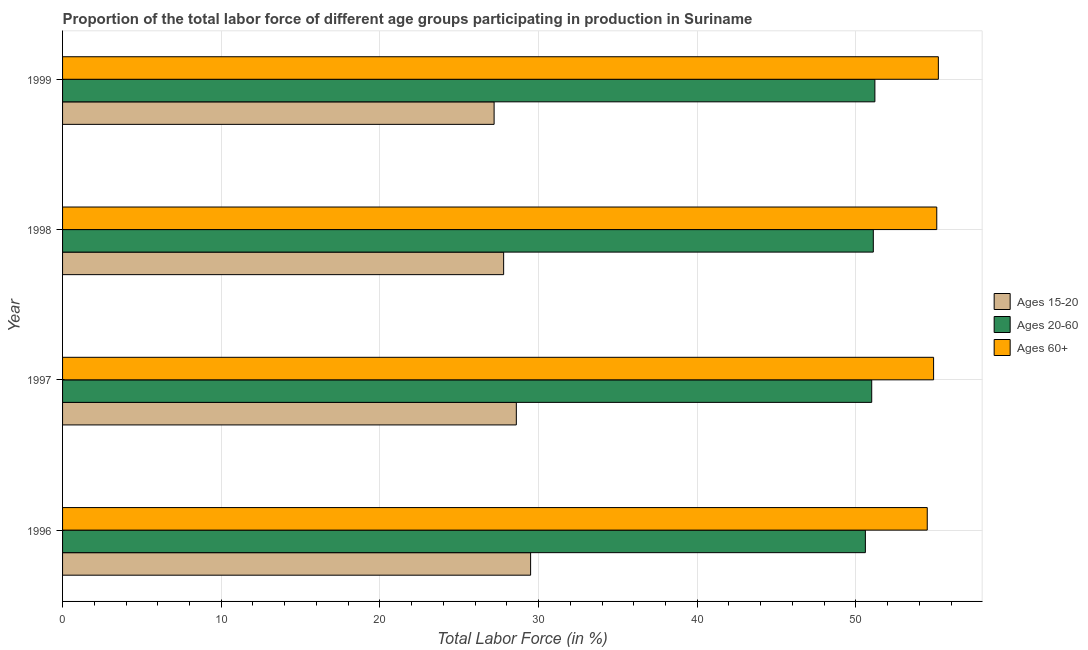How many different coloured bars are there?
Give a very brief answer. 3. How many groups of bars are there?
Provide a short and direct response. 4. How many bars are there on the 3rd tick from the top?
Offer a very short reply. 3. What is the percentage of labor force above age 60 in 1996?
Provide a succinct answer. 54.5. Across all years, what is the maximum percentage of labor force within the age group 15-20?
Give a very brief answer. 29.5. Across all years, what is the minimum percentage of labor force above age 60?
Offer a very short reply. 54.5. In which year was the percentage of labor force within the age group 15-20 minimum?
Your response must be concise. 1999. What is the total percentage of labor force within the age group 20-60 in the graph?
Your answer should be compact. 203.9. What is the difference between the percentage of labor force within the age group 15-20 in 1997 and that in 1999?
Provide a succinct answer. 1.4. What is the difference between the percentage of labor force within the age group 15-20 in 1998 and the percentage of labor force above age 60 in 1996?
Provide a short and direct response. -26.7. What is the average percentage of labor force within the age group 15-20 per year?
Keep it short and to the point. 28.27. In how many years, is the percentage of labor force within the age group 15-20 greater than 54 %?
Offer a very short reply. 0. What is the ratio of the percentage of labor force within the age group 15-20 in 1996 to that in 1997?
Offer a very short reply. 1.03. Is the difference between the percentage of labor force within the age group 20-60 in 1998 and 1999 greater than the difference between the percentage of labor force above age 60 in 1998 and 1999?
Provide a short and direct response. No. What is the difference between the highest and the second highest percentage of labor force within the age group 20-60?
Keep it short and to the point. 0.1. What is the difference between the highest and the lowest percentage of labor force within the age group 15-20?
Offer a very short reply. 2.3. What does the 3rd bar from the top in 1996 represents?
Make the answer very short. Ages 15-20. What does the 1st bar from the bottom in 1996 represents?
Ensure brevity in your answer.  Ages 15-20. Is it the case that in every year, the sum of the percentage of labor force within the age group 15-20 and percentage of labor force within the age group 20-60 is greater than the percentage of labor force above age 60?
Make the answer very short. Yes. How many bars are there?
Make the answer very short. 12. Are all the bars in the graph horizontal?
Ensure brevity in your answer.  Yes. How many years are there in the graph?
Offer a terse response. 4. Are the values on the major ticks of X-axis written in scientific E-notation?
Offer a terse response. No. Does the graph contain any zero values?
Keep it short and to the point. No. Does the graph contain grids?
Offer a terse response. Yes. How many legend labels are there?
Give a very brief answer. 3. How are the legend labels stacked?
Offer a very short reply. Vertical. What is the title of the graph?
Make the answer very short. Proportion of the total labor force of different age groups participating in production in Suriname. What is the label or title of the X-axis?
Make the answer very short. Total Labor Force (in %). What is the Total Labor Force (in %) in Ages 15-20 in 1996?
Your answer should be compact. 29.5. What is the Total Labor Force (in %) of Ages 20-60 in 1996?
Ensure brevity in your answer.  50.6. What is the Total Labor Force (in %) in Ages 60+ in 1996?
Provide a succinct answer. 54.5. What is the Total Labor Force (in %) of Ages 15-20 in 1997?
Make the answer very short. 28.6. What is the Total Labor Force (in %) of Ages 60+ in 1997?
Your answer should be compact. 54.9. What is the Total Labor Force (in %) of Ages 15-20 in 1998?
Offer a very short reply. 27.8. What is the Total Labor Force (in %) in Ages 20-60 in 1998?
Keep it short and to the point. 51.1. What is the Total Labor Force (in %) in Ages 60+ in 1998?
Your response must be concise. 55.1. What is the Total Labor Force (in %) of Ages 15-20 in 1999?
Keep it short and to the point. 27.2. What is the Total Labor Force (in %) of Ages 20-60 in 1999?
Keep it short and to the point. 51.2. What is the Total Labor Force (in %) in Ages 60+ in 1999?
Offer a very short reply. 55.2. Across all years, what is the maximum Total Labor Force (in %) of Ages 15-20?
Offer a very short reply. 29.5. Across all years, what is the maximum Total Labor Force (in %) of Ages 20-60?
Provide a succinct answer. 51.2. Across all years, what is the maximum Total Labor Force (in %) in Ages 60+?
Make the answer very short. 55.2. Across all years, what is the minimum Total Labor Force (in %) of Ages 15-20?
Provide a short and direct response. 27.2. Across all years, what is the minimum Total Labor Force (in %) of Ages 20-60?
Give a very brief answer. 50.6. Across all years, what is the minimum Total Labor Force (in %) of Ages 60+?
Keep it short and to the point. 54.5. What is the total Total Labor Force (in %) of Ages 15-20 in the graph?
Ensure brevity in your answer.  113.1. What is the total Total Labor Force (in %) in Ages 20-60 in the graph?
Provide a succinct answer. 203.9. What is the total Total Labor Force (in %) in Ages 60+ in the graph?
Offer a terse response. 219.7. What is the difference between the Total Labor Force (in %) of Ages 20-60 in 1996 and that in 1997?
Provide a succinct answer. -0.4. What is the difference between the Total Labor Force (in %) in Ages 60+ in 1996 and that in 1997?
Provide a succinct answer. -0.4. What is the difference between the Total Labor Force (in %) of Ages 15-20 in 1996 and that in 1998?
Provide a short and direct response. 1.7. What is the difference between the Total Labor Force (in %) in Ages 60+ in 1996 and that in 1998?
Offer a terse response. -0.6. What is the difference between the Total Labor Force (in %) in Ages 20-60 in 1996 and that in 1999?
Make the answer very short. -0.6. What is the difference between the Total Labor Force (in %) in Ages 60+ in 1996 and that in 1999?
Give a very brief answer. -0.7. What is the difference between the Total Labor Force (in %) in Ages 15-20 in 1997 and that in 1998?
Provide a short and direct response. 0.8. What is the difference between the Total Labor Force (in %) in Ages 60+ in 1997 and that in 1998?
Your answer should be compact. -0.2. What is the difference between the Total Labor Force (in %) of Ages 15-20 in 1997 and that in 1999?
Offer a terse response. 1.4. What is the difference between the Total Labor Force (in %) of Ages 20-60 in 1997 and that in 1999?
Make the answer very short. -0.2. What is the difference between the Total Labor Force (in %) in Ages 15-20 in 1996 and the Total Labor Force (in %) in Ages 20-60 in 1997?
Your response must be concise. -21.5. What is the difference between the Total Labor Force (in %) of Ages 15-20 in 1996 and the Total Labor Force (in %) of Ages 60+ in 1997?
Give a very brief answer. -25.4. What is the difference between the Total Labor Force (in %) in Ages 20-60 in 1996 and the Total Labor Force (in %) in Ages 60+ in 1997?
Ensure brevity in your answer.  -4.3. What is the difference between the Total Labor Force (in %) of Ages 15-20 in 1996 and the Total Labor Force (in %) of Ages 20-60 in 1998?
Offer a very short reply. -21.6. What is the difference between the Total Labor Force (in %) of Ages 15-20 in 1996 and the Total Labor Force (in %) of Ages 60+ in 1998?
Offer a very short reply. -25.6. What is the difference between the Total Labor Force (in %) in Ages 20-60 in 1996 and the Total Labor Force (in %) in Ages 60+ in 1998?
Your response must be concise. -4.5. What is the difference between the Total Labor Force (in %) of Ages 15-20 in 1996 and the Total Labor Force (in %) of Ages 20-60 in 1999?
Provide a succinct answer. -21.7. What is the difference between the Total Labor Force (in %) of Ages 15-20 in 1996 and the Total Labor Force (in %) of Ages 60+ in 1999?
Ensure brevity in your answer.  -25.7. What is the difference between the Total Labor Force (in %) of Ages 15-20 in 1997 and the Total Labor Force (in %) of Ages 20-60 in 1998?
Ensure brevity in your answer.  -22.5. What is the difference between the Total Labor Force (in %) in Ages 15-20 in 1997 and the Total Labor Force (in %) in Ages 60+ in 1998?
Provide a short and direct response. -26.5. What is the difference between the Total Labor Force (in %) in Ages 20-60 in 1997 and the Total Labor Force (in %) in Ages 60+ in 1998?
Provide a succinct answer. -4.1. What is the difference between the Total Labor Force (in %) of Ages 15-20 in 1997 and the Total Labor Force (in %) of Ages 20-60 in 1999?
Provide a succinct answer. -22.6. What is the difference between the Total Labor Force (in %) in Ages 15-20 in 1997 and the Total Labor Force (in %) in Ages 60+ in 1999?
Your response must be concise. -26.6. What is the difference between the Total Labor Force (in %) in Ages 15-20 in 1998 and the Total Labor Force (in %) in Ages 20-60 in 1999?
Your response must be concise. -23.4. What is the difference between the Total Labor Force (in %) of Ages 15-20 in 1998 and the Total Labor Force (in %) of Ages 60+ in 1999?
Offer a terse response. -27.4. What is the difference between the Total Labor Force (in %) of Ages 20-60 in 1998 and the Total Labor Force (in %) of Ages 60+ in 1999?
Keep it short and to the point. -4.1. What is the average Total Labor Force (in %) of Ages 15-20 per year?
Offer a terse response. 28.27. What is the average Total Labor Force (in %) in Ages 20-60 per year?
Your response must be concise. 50.98. What is the average Total Labor Force (in %) of Ages 60+ per year?
Provide a succinct answer. 54.92. In the year 1996, what is the difference between the Total Labor Force (in %) of Ages 15-20 and Total Labor Force (in %) of Ages 20-60?
Offer a very short reply. -21.1. In the year 1997, what is the difference between the Total Labor Force (in %) of Ages 15-20 and Total Labor Force (in %) of Ages 20-60?
Your response must be concise. -22.4. In the year 1997, what is the difference between the Total Labor Force (in %) of Ages 15-20 and Total Labor Force (in %) of Ages 60+?
Provide a short and direct response. -26.3. In the year 1998, what is the difference between the Total Labor Force (in %) in Ages 15-20 and Total Labor Force (in %) in Ages 20-60?
Your response must be concise. -23.3. In the year 1998, what is the difference between the Total Labor Force (in %) of Ages 15-20 and Total Labor Force (in %) of Ages 60+?
Provide a short and direct response. -27.3. In the year 1998, what is the difference between the Total Labor Force (in %) of Ages 20-60 and Total Labor Force (in %) of Ages 60+?
Offer a very short reply. -4. In the year 1999, what is the difference between the Total Labor Force (in %) of Ages 15-20 and Total Labor Force (in %) of Ages 60+?
Your response must be concise. -28. In the year 1999, what is the difference between the Total Labor Force (in %) of Ages 20-60 and Total Labor Force (in %) of Ages 60+?
Offer a very short reply. -4. What is the ratio of the Total Labor Force (in %) in Ages 15-20 in 1996 to that in 1997?
Ensure brevity in your answer.  1.03. What is the ratio of the Total Labor Force (in %) in Ages 15-20 in 1996 to that in 1998?
Give a very brief answer. 1.06. What is the ratio of the Total Labor Force (in %) of Ages 20-60 in 1996 to that in 1998?
Offer a terse response. 0.99. What is the ratio of the Total Labor Force (in %) of Ages 60+ in 1996 to that in 1998?
Make the answer very short. 0.99. What is the ratio of the Total Labor Force (in %) of Ages 15-20 in 1996 to that in 1999?
Offer a terse response. 1.08. What is the ratio of the Total Labor Force (in %) in Ages 20-60 in 1996 to that in 1999?
Give a very brief answer. 0.99. What is the ratio of the Total Labor Force (in %) in Ages 60+ in 1996 to that in 1999?
Give a very brief answer. 0.99. What is the ratio of the Total Labor Force (in %) in Ages 15-20 in 1997 to that in 1998?
Keep it short and to the point. 1.03. What is the ratio of the Total Labor Force (in %) in Ages 20-60 in 1997 to that in 1998?
Offer a terse response. 1. What is the ratio of the Total Labor Force (in %) of Ages 60+ in 1997 to that in 1998?
Offer a very short reply. 1. What is the ratio of the Total Labor Force (in %) of Ages 15-20 in 1997 to that in 1999?
Give a very brief answer. 1.05. What is the ratio of the Total Labor Force (in %) in Ages 60+ in 1997 to that in 1999?
Offer a terse response. 0.99. What is the ratio of the Total Labor Force (in %) of Ages 15-20 in 1998 to that in 1999?
Your answer should be compact. 1.02. What is the ratio of the Total Labor Force (in %) of Ages 20-60 in 1998 to that in 1999?
Keep it short and to the point. 1. What is the ratio of the Total Labor Force (in %) of Ages 60+ in 1998 to that in 1999?
Provide a succinct answer. 1. What is the difference between the highest and the second highest Total Labor Force (in %) in Ages 20-60?
Offer a very short reply. 0.1. What is the difference between the highest and the second highest Total Labor Force (in %) in Ages 60+?
Give a very brief answer. 0.1. 